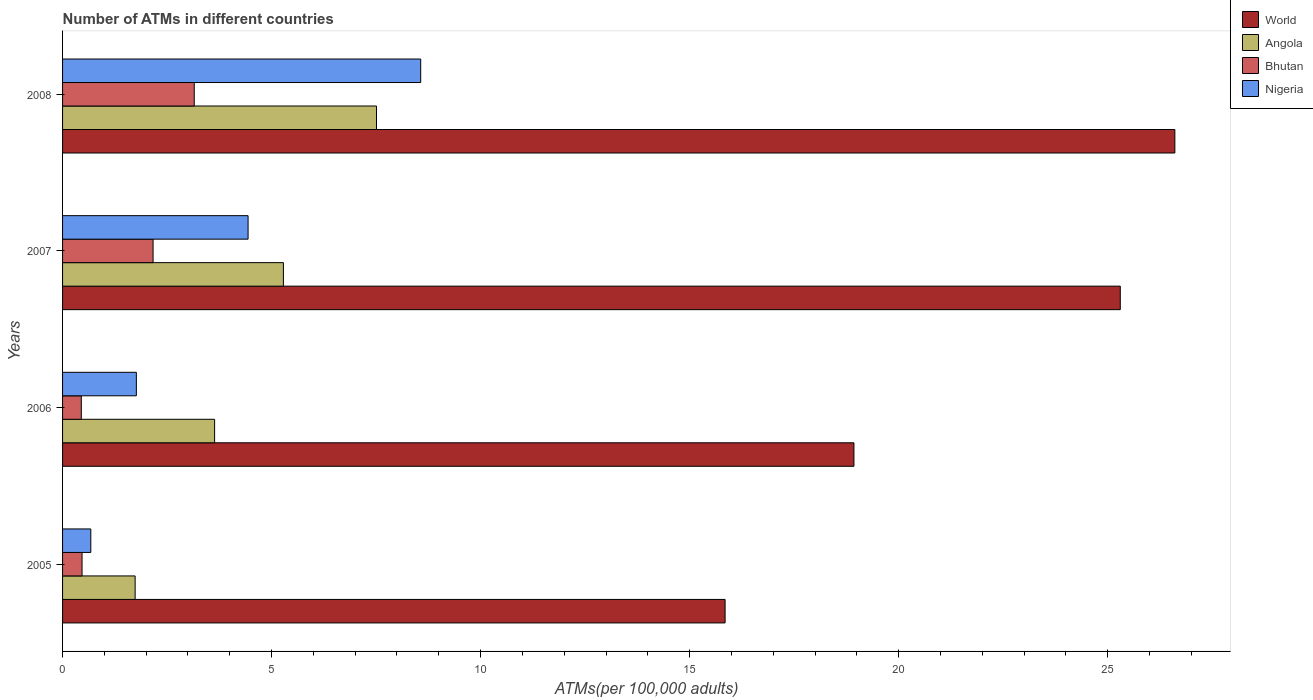Are the number of bars on each tick of the Y-axis equal?
Offer a very short reply. Yes. How many bars are there on the 3rd tick from the bottom?
Provide a short and direct response. 4. In how many cases, is the number of bars for a given year not equal to the number of legend labels?
Make the answer very short. 0. What is the number of ATMs in Nigeria in 2005?
Offer a terse response. 0.68. Across all years, what is the maximum number of ATMs in Bhutan?
Make the answer very short. 3.15. Across all years, what is the minimum number of ATMs in Bhutan?
Give a very brief answer. 0.45. What is the total number of ATMs in Bhutan in the graph?
Give a very brief answer. 6.23. What is the difference between the number of ATMs in Angola in 2006 and that in 2007?
Your answer should be very brief. -1.65. What is the difference between the number of ATMs in Nigeria in 2006 and the number of ATMs in World in 2005?
Give a very brief answer. -14.08. What is the average number of ATMs in Angola per year?
Your response must be concise. 4.54. In the year 2008, what is the difference between the number of ATMs in Bhutan and number of ATMs in World?
Provide a short and direct response. -23.46. What is the ratio of the number of ATMs in Bhutan in 2006 to that in 2008?
Your answer should be compact. 0.14. Is the number of ATMs in Angola in 2005 less than that in 2007?
Provide a short and direct response. Yes. What is the difference between the highest and the second highest number of ATMs in Nigeria?
Your response must be concise. 4.13. What is the difference between the highest and the lowest number of ATMs in Nigeria?
Your answer should be compact. 7.89. Is the sum of the number of ATMs in Nigeria in 2005 and 2007 greater than the maximum number of ATMs in World across all years?
Provide a short and direct response. No. Is it the case that in every year, the sum of the number of ATMs in Bhutan and number of ATMs in World is greater than the sum of number of ATMs in Angola and number of ATMs in Nigeria?
Your response must be concise. No. How many legend labels are there?
Your answer should be compact. 4. What is the title of the graph?
Your response must be concise. Number of ATMs in different countries. What is the label or title of the X-axis?
Your response must be concise. ATMs(per 100,0 adults). What is the label or title of the Y-axis?
Keep it short and to the point. Years. What is the ATMs(per 100,000 adults) of World in 2005?
Your answer should be very brief. 15.85. What is the ATMs(per 100,000 adults) of Angola in 2005?
Your answer should be very brief. 1.74. What is the ATMs(per 100,000 adults) of Bhutan in 2005?
Your answer should be very brief. 0.47. What is the ATMs(per 100,000 adults) of Nigeria in 2005?
Provide a succinct answer. 0.68. What is the ATMs(per 100,000 adults) of World in 2006?
Provide a short and direct response. 18.93. What is the ATMs(per 100,000 adults) in Angola in 2006?
Make the answer very short. 3.64. What is the ATMs(per 100,000 adults) of Bhutan in 2006?
Offer a very short reply. 0.45. What is the ATMs(per 100,000 adults) of Nigeria in 2006?
Your answer should be compact. 1.77. What is the ATMs(per 100,000 adults) of World in 2007?
Keep it short and to the point. 25.3. What is the ATMs(per 100,000 adults) of Angola in 2007?
Keep it short and to the point. 5.28. What is the ATMs(per 100,000 adults) in Bhutan in 2007?
Provide a short and direct response. 2.17. What is the ATMs(per 100,000 adults) of Nigeria in 2007?
Your answer should be very brief. 4.44. What is the ATMs(per 100,000 adults) in World in 2008?
Offer a terse response. 26.61. What is the ATMs(per 100,000 adults) of Angola in 2008?
Make the answer very short. 7.51. What is the ATMs(per 100,000 adults) in Bhutan in 2008?
Your answer should be compact. 3.15. What is the ATMs(per 100,000 adults) of Nigeria in 2008?
Offer a very short reply. 8.57. Across all years, what is the maximum ATMs(per 100,000 adults) in World?
Your answer should be compact. 26.61. Across all years, what is the maximum ATMs(per 100,000 adults) of Angola?
Give a very brief answer. 7.51. Across all years, what is the maximum ATMs(per 100,000 adults) in Bhutan?
Your answer should be compact. 3.15. Across all years, what is the maximum ATMs(per 100,000 adults) of Nigeria?
Ensure brevity in your answer.  8.57. Across all years, what is the minimum ATMs(per 100,000 adults) of World?
Your answer should be very brief. 15.85. Across all years, what is the minimum ATMs(per 100,000 adults) of Angola?
Provide a short and direct response. 1.74. Across all years, what is the minimum ATMs(per 100,000 adults) of Bhutan?
Ensure brevity in your answer.  0.45. Across all years, what is the minimum ATMs(per 100,000 adults) in Nigeria?
Ensure brevity in your answer.  0.68. What is the total ATMs(per 100,000 adults) of World in the graph?
Your answer should be very brief. 86.69. What is the total ATMs(per 100,000 adults) of Angola in the graph?
Give a very brief answer. 18.17. What is the total ATMs(per 100,000 adults) of Bhutan in the graph?
Make the answer very short. 6.23. What is the total ATMs(per 100,000 adults) of Nigeria in the graph?
Make the answer very short. 15.45. What is the difference between the ATMs(per 100,000 adults) in World in 2005 and that in 2006?
Your answer should be compact. -3.08. What is the difference between the ATMs(per 100,000 adults) in Angola in 2005 and that in 2006?
Provide a short and direct response. -1.9. What is the difference between the ATMs(per 100,000 adults) of Bhutan in 2005 and that in 2006?
Provide a short and direct response. 0.02. What is the difference between the ATMs(per 100,000 adults) of Nigeria in 2005 and that in 2006?
Offer a terse response. -1.09. What is the difference between the ATMs(per 100,000 adults) in World in 2005 and that in 2007?
Offer a very short reply. -9.45. What is the difference between the ATMs(per 100,000 adults) of Angola in 2005 and that in 2007?
Offer a very short reply. -3.55. What is the difference between the ATMs(per 100,000 adults) of Bhutan in 2005 and that in 2007?
Provide a short and direct response. -1.7. What is the difference between the ATMs(per 100,000 adults) of Nigeria in 2005 and that in 2007?
Provide a succinct answer. -3.76. What is the difference between the ATMs(per 100,000 adults) of World in 2005 and that in 2008?
Give a very brief answer. -10.76. What is the difference between the ATMs(per 100,000 adults) in Angola in 2005 and that in 2008?
Keep it short and to the point. -5.77. What is the difference between the ATMs(per 100,000 adults) in Bhutan in 2005 and that in 2008?
Make the answer very short. -2.68. What is the difference between the ATMs(per 100,000 adults) of Nigeria in 2005 and that in 2008?
Offer a very short reply. -7.89. What is the difference between the ATMs(per 100,000 adults) in World in 2006 and that in 2007?
Keep it short and to the point. -6.37. What is the difference between the ATMs(per 100,000 adults) of Angola in 2006 and that in 2007?
Make the answer very short. -1.65. What is the difference between the ATMs(per 100,000 adults) in Bhutan in 2006 and that in 2007?
Your response must be concise. -1.72. What is the difference between the ATMs(per 100,000 adults) of Nigeria in 2006 and that in 2007?
Your answer should be very brief. -2.67. What is the difference between the ATMs(per 100,000 adults) of World in 2006 and that in 2008?
Offer a terse response. -7.68. What is the difference between the ATMs(per 100,000 adults) in Angola in 2006 and that in 2008?
Your answer should be very brief. -3.87. What is the difference between the ATMs(per 100,000 adults) in Bhutan in 2006 and that in 2008?
Keep it short and to the point. -2.7. What is the difference between the ATMs(per 100,000 adults) of Nigeria in 2006 and that in 2008?
Offer a terse response. -6.8. What is the difference between the ATMs(per 100,000 adults) of World in 2007 and that in 2008?
Offer a very short reply. -1.31. What is the difference between the ATMs(per 100,000 adults) of Angola in 2007 and that in 2008?
Ensure brevity in your answer.  -2.23. What is the difference between the ATMs(per 100,000 adults) in Bhutan in 2007 and that in 2008?
Your answer should be very brief. -0.98. What is the difference between the ATMs(per 100,000 adults) of Nigeria in 2007 and that in 2008?
Your answer should be very brief. -4.13. What is the difference between the ATMs(per 100,000 adults) of World in 2005 and the ATMs(per 100,000 adults) of Angola in 2006?
Your answer should be compact. 12.21. What is the difference between the ATMs(per 100,000 adults) of World in 2005 and the ATMs(per 100,000 adults) of Bhutan in 2006?
Provide a succinct answer. 15.4. What is the difference between the ATMs(per 100,000 adults) in World in 2005 and the ATMs(per 100,000 adults) in Nigeria in 2006?
Keep it short and to the point. 14.08. What is the difference between the ATMs(per 100,000 adults) in Angola in 2005 and the ATMs(per 100,000 adults) in Bhutan in 2006?
Provide a succinct answer. 1.29. What is the difference between the ATMs(per 100,000 adults) of Angola in 2005 and the ATMs(per 100,000 adults) of Nigeria in 2006?
Give a very brief answer. -0.03. What is the difference between the ATMs(per 100,000 adults) in Bhutan in 2005 and the ATMs(per 100,000 adults) in Nigeria in 2006?
Give a very brief answer. -1.3. What is the difference between the ATMs(per 100,000 adults) of World in 2005 and the ATMs(per 100,000 adults) of Angola in 2007?
Make the answer very short. 10.57. What is the difference between the ATMs(per 100,000 adults) of World in 2005 and the ATMs(per 100,000 adults) of Bhutan in 2007?
Offer a terse response. 13.68. What is the difference between the ATMs(per 100,000 adults) of World in 2005 and the ATMs(per 100,000 adults) of Nigeria in 2007?
Your answer should be very brief. 11.41. What is the difference between the ATMs(per 100,000 adults) of Angola in 2005 and the ATMs(per 100,000 adults) of Bhutan in 2007?
Keep it short and to the point. -0.43. What is the difference between the ATMs(per 100,000 adults) in Angola in 2005 and the ATMs(per 100,000 adults) in Nigeria in 2007?
Your response must be concise. -2.7. What is the difference between the ATMs(per 100,000 adults) of Bhutan in 2005 and the ATMs(per 100,000 adults) of Nigeria in 2007?
Your response must be concise. -3.97. What is the difference between the ATMs(per 100,000 adults) of World in 2005 and the ATMs(per 100,000 adults) of Angola in 2008?
Offer a terse response. 8.34. What is the difference between the ATMs(per 100,000 adults) in World in 2005 and the ATMs(per 100,000 adults) in Bhutan in 2008?
Ensure brevity in your answer.  12.7. What is the difference between the ATMs(per 100,000 adults) in World in 2005 and the ATMs(per 100,000 adults) in Nigeria in 2008?
Give a very brief answer. 7.28. What is the difference between the ATMs(per 100,000 adults) in Angola in 2005 and the ATMs(per 100,000 adults) in Bhutan in 2008?
Make the answer very short. -1.41. What is the difference between the ATMs(per 100,000 adults) in Angola in 2005 and the ATMs(per 100,000 adults) in Nigeria in 2008?
Provide a short and direct response. -6.83. What is the difference between the ATMs(per 100,000 adults) in Bhutan in 2005 and the ATMs(per 100,000 adults) in Nigeria in 2008?
Make the answer very short. -8.1. What is the difference between the ATMs(per 100,000 adults) in World in 2006 and the ATMs(per 100,000 adults) in Angola in 2007?
Offer a terse response. 13.65. What is the difference between the ATMs(per 100,000 adults) in World in 2006 and the ATMs(per 100,000 adults) in Bhutan in 2007?
Offer a very short reply. 16.77. What is the difference between the ATMs(per 100,000 adults) in World in 2006 and the ATMs(per 100,000 adults) in Nigeria in 2007?
Your answer should be compact. 14.49. What is the difference between the ATMs(per 100,000 adults) in Angola in 2006 and the ATMs(per 100,000 adults) in Bhutan in 2007?
Ensure brevity in your answer.  1.47. What is the difference between the ATMs(per 100,000 adults) in Angola in 2006 and the ATMs(per 100,000 adults) in Nigeria in 2007?
Make the answer very short. -0.8. What is the difference between the ATMs(per 100,000 adults) of Bhutan in 2006 and the ATMs(per 100,000 adults) of Nigeria in 2007?
Ensure brevity in your answer.  -3.99. What is the difference between the ATMs(per 100,000 adults) of World in 2006 and the ATMs(per 100,000 adults) of Angola in 2008?
Your answer should be very brief. 11.42. What is the difference between the ATMs(per 100,000 adults) in World in 2006 and the ATMs(per 100,000 adults) in Bhutan in 2008?
Your answer should be compact. 15.78. What is the difference between the ATMs(per 100,000 adults) in World in 2006 and the ATMs(per 100,000 adults) in Nigeria in 2008?
Your response must be concise. 10.36. What is the difference between the ATMs(per 100,000 adults) of Angola in 2006 and the ATMs(per 100,000 adults) of Bhutan in 2008?
Offer a terse response. 0.49. What is the difference between the ATMs(per 100,000 adults) in Angola in 2006 and the ATMs(per 100,000 adults) in Nigeria in 2008?
Your answer should be compact. -4.93. What is the difference between the ATMs(per 100,000 adults) in Bhutan in 2006 and the ATMs(per 100,000 adults) in Nigeria in 2008?
Provide a succinct answer. -8.12. What is the difference between the ATMs(per 100,000 adults) in World in 2007 and the ATMs(per 100,000 adults) in Angola in 2008?
Your response must be concise. 17.79. What is the difference between the ATMs(per 100,000 adults) of World in 2007 and the ATMs(per 100,000 adults) of Bhutan in 2008?
Provide a succinct answer. 22.15. What is the difference between the ATMs(per 100,000 adults) in World in 2007 and the ATMs(per 100,000 adults) in Nigeria in 2008?
Offer a very short reply. 16.74. What is the difference between the ATMs(per 100,000 adults) of Angola in 2007 and the ATMs(per 100,000 adults) of Bhutan in 2008?
Offer a terse response. 2.13. What is the difference between the ATMs(per 100,000 adults) in Angola in 2007 and the ATMs(per 100,000 adults) in Nigeria in 2008?
Offer a very short reply. -3.28. What is the difference between the ATMs(per 100,000 adults) in Bhutan in 2007 and the ATMs(per 100,000 adults) in Nigeria in 2008?
Your answer should be very brief. -6.4. What is the average ATMs(per 100,000 adults) in World per year?
Provide a succinct answer. 21.67. What is the average ATMs(per 100,000 adults) in Angola per year?
Provide a short and direct response. 4.54. What is the average ATMs(per 100,000 adults) in Bhutan per year?
Give a very brief answer. 1.56. What is the average ATMs(per 100,000 adults) in Nigeria per year?
Your answer should be very brief. 3.86. In the year 2005, what is the difference between the ATMs(per 100,000 adults) of World and ATMs(per 100,000 adults) of Angola?
Your answer should be very brief. 14.11. In the year 2005, what is the difference between the ATMs(per 100,000 adults) in World and ATMs(per 100,000 adults) in Bhutan?
Your answer should be very brief. 15.38. In the year 2005, what is the difference between the ATMs(per 100,000 adults) in World and ATMs(per 100,000 adults) in Nigeria?
Give a very brief answer. 15.17. In the year 2005, what is the difference between the ATMs(per 100,000 adults) in Angola and ATMs(per 100,000 adults) in Bhutan?
Give a very brief answer. 1.27. In the year 2005, what is the difference between the ATMs(per 100,000 adults) of Angola and ATMs(per 100,000 adults) of Nigeria?
Offer a very short reply. 1.06. In the year 2005, what is the difference between the ATMs(per 100,000 adults) of Bhutan and ATMs(per 100,000 adults) of Nigeria?
Give a very brief answer. -0.21. In the year 2006, what is the difference between the ATMs(per 100,000 adults) in World and ATMs(per 100,000 adults) in Angola?
Your answer should be very brief. 15.29. In the year 2006, what is the difference between the ATMs(per 100,000 adults) in World and ATMs(per 100,000 adults) in Bhutan?
Give a very brief answer. 18.48. In the year 2006, what is the difference between the ATMs(per 100,000 adults) of World and ATMs(per 100,000 adults) of Nigeria?
Keep it short and to the point. 17.17. In the year 2006, what is the difference between the ATMs(per 100,000 adults) in Angola and ATMs(per 100,000 adults) in Bhutan?
Ensure brevity in your answer.  3.19. In the year 2006, what is the difference between the ATMs(per 100,000 adults) in Angola and ATMs(per 100,000 adults) in Nigeria?
Keep it short and to the point. 1.87. In the year 2006, what is the difference between the ATMs(per 100,000 adults) of Bhutan and ATMs(per 100,000 adults) of Nigeria?
Provide a succinct answer. -1.32. In the year 2007, what is the difference between the ATMs(per 100,000 adults) of World and ATMs(per 100,000 adults) of Angola?
Give a very brief answer. 20.02. In the year 2007, what is the difference between the ATMs(per 100,000 adults) of World and ATMs(per 100,000 adults) of Bhutan?
Offer a very short reply. 23.14. In the year 2007, what is the difference between the ATMs(per 100,000 adults) of World and ATMs(per 100,000 adults) of Nigeria?
Your answer should be very brief. 20.86. In the year 2007, what is the difference between the ATMs(per 100,000 adults) in Angola and ATMs(per 100,000 adults) in Bhutan?
Provide a short and direct response. 3.12. In the year 2007, what is the difference between the ATMs(per 100,000 adults) in Angola and ATMs(per 100,000 adults) in Nigeria?
Your answer should be compact. 0.85. In the year 2007, what is the difference between the ATMs(per 100,000 adults) in Bhutan and ATMs(per 100,000 adults) in Nigeria?
Your response must be concise. -2.27. In the year 2008, what is the difference between the ATMs(per 100,000 adults) of World and ATMs(per 100,000 adults) of Angola?
Ensure brevity in your answer.  19.1. In the year 2008, what is the difference between the ATMs(per 100,000 adults) in World and ATMs(per 100,000 adults) in Bhutan?
Give a very brief answer. 23.46. In the year 2008, what is the difference between the ATMs(per 100,000 adults) in World and ATMs(per 100,000 adults) in Nigeria?
Offer a very short reply. 18.04. In the year 2008, what is the difference between the ATMs(per 100,000 adults) in Angola and ATMs(per 100,000 adults) in Bhutan?
Your answer should be very brief. 4.36. In the year 2008, what is the difference between the ATMs(per 100,000 adults) in Angola and ATMs(per 100,000 adults) in Nigeria?
Your answer should be compact. -1.06. In the year 2008, what is the difference between the ATMs(per 100,000 adults) in Bhutan and ATMs(per 100,000 adults) in Nigeria?
Offer a very short reply. -5.42. What is the ratio of the ATMs(per 100,000 adults) in World in 2005 to that in 2006?
Keep it short and to the point. 0.84. What is the ratio of the ATMs(per 100,000 adults) of Angola in 2005 to that in 2006?
Give a very brief answer. 0.48. What is the ratio of the ATMs(per 100,000 adults) in Bhutan in 2005 to that in 2006?
Give a very brief answer. 1.04. What is the ratio of the ATMs(per 100,000 adults) in Nigeria in 2005 to that in 2006?
Your answer should be compact. 0.38. What is the ratio of the ATMs(per 100,000 adults) in World in 2005 to that in 2007?
Provide a short and direct response. 0.63. What is the ratio of the ATMs(per 100,000 adults) in Angola in 2005 to that in 2007?
Ensure brevity in your answer.  0.33. What is the ratio of the ATMs(per 100,000 adults) of Bhutan in 2005 to that in 2007?
Your answer should be very brief. 0.22. What is the ratio of the ATMs(per 100,000 adults) in Nigeria in 2005 to that in 2007?
Your answer should be compact. 0.15. What is the ratio of the ATMs(per 100,000 adults) of World in 2005 to that in 2008?
Offer a very short reply. 0.6. What is the ratio of the ATMs(per 100,000 adults) of Angola in 2005 to that in 2008?
Provide a short and direct response. 0.23. What is the ratio of the ATMs(per 100,000 adults) of Bhutan in 2005 to that in 2008?
Your answer should be very brief. 0.15. What is the ratio of the ATMs(per 100,000 adults) of Nigeria in 2005 to that in 2008?
Keep it short and to the point. 0.08. What is the ratio of the ATMs(per 100,000 adults) in World in 2006 to that in 2007?
Ensure brevity in your answer.  0.75. What is the ratio of the ATMs(per 100,000 adults) in Angola in 2006 to that in 2007?
Offer a very short reply. 0.69. What is the ratio of the ATMs(per 100,000 adults) in Bhutan in 2006 to that in 2007?
Provide a short and direct response. 0.21. What is the ratio of the ATMs(per 100,000 adults) of Nigeria in 2006 to that in 2007?
Ensure brevity in your answer.  0.4. What is the ratio of the ATMs(per 100,000 adults) of World in 2006 to that in 2008?
Your answer should be very brief. 0.71. What is the ratio of the ATMs(per 100,000 adults) of Angola in 2006 to that in 2008?
Provide a short and direct response. 0.48. What is the ratio of the ATMs(per 100,000 adults) in Bhutan in 2006 to that in 2008?
Provide a succinct answer. 0.14. What is the ratio of the ATMs(per 100,000 adults) in Nigeria in 2006 to that in 2008?
Give a very brief answer. 0.21. What is the ratio of the ATMs(per 100,000 adults) in World in 2007 to that in 2008?
Your response must be concise. 0.95. What is the ratio of the ATMs(per 100,000 adults) of Angola in 2007 to that in 2008?
Your answer should be very brief. 0.7. What is the ratio of the ATMs(per 100,000 adults) in Bhutan in 2007 to that in 2008?
Give a very brief answer. 0.69. What is the ratio of the ATMs(per 100,000 adults) in Nigeria in 2007 to that in 2008?
Your response must be concise. 0.52. What is the difference between the highest and the second highest ATMs(per 100,000 adults) in World?
Your answer should be compact. 1.31. What is the difference between the highest and the second highest ATMs(per 100,000 adults) of Angola?
Your response must be concise. 2.23. What is the difference between the highest and the second highest ATMs(per 100,000 adults) of Bhutan?
Give a very brief answer. 0.98. What is the difference between the highest and the second highest ATMs(per 100,000 adults) of Nigeria?
Give a very brief answer. 4.13. What is the difference between the highest and the lowest ATMs(per 100,000 adults) in World?
Make the answer very short. 10.76. What is the difference between the highest and the lowest ATMs(per 100,000 adults) in Angola?
Provide a succinct answer. 5.77. What is the difference between the highest and the lowest ATMs(per 100,000 adults) of Bhutan?
Offer a terse response. 2.7. What is the difference between the highest and the lowest ATMs(per 100,000 adults) in Nigeria?
Give a very brief answer. 7.89. 